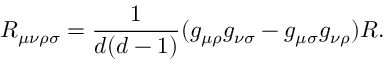Convert formula to latex. <formula><loc_0><loc_0><loc_500><loc_500>R _ { \mu \nu \rho \sigma } = \frac { 1 } { d ( d - 1 ) } ( g _ { \mu \rho } g _ { \nu \sigma } - g _ { \mu \sigma } g _ { \nu \rho } ) R .</formula> 